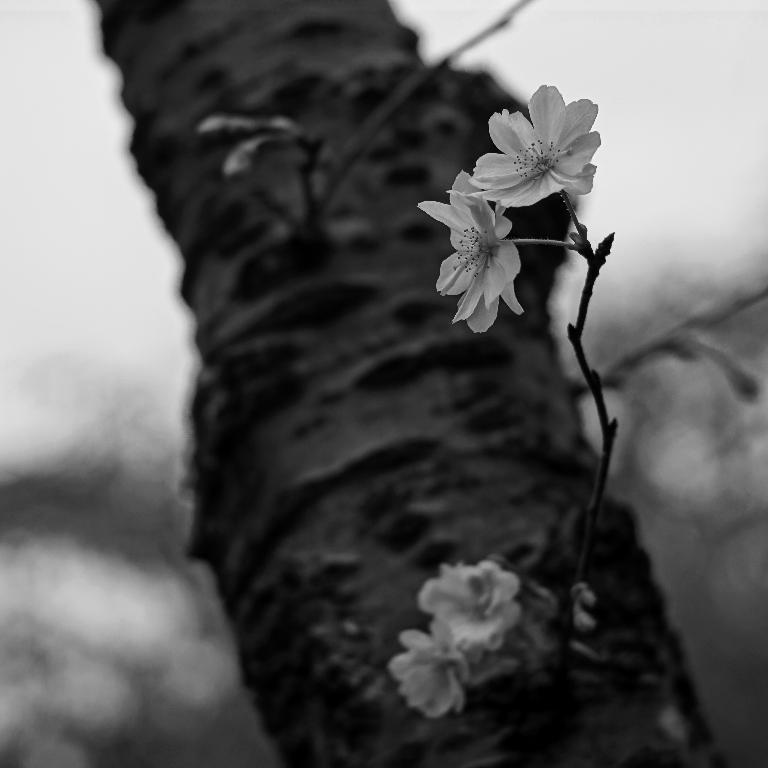What is the main subject of the image? The main subject of the image is flowers. Can you describe the flowers in the image? The flowers are located in the center of the image. What can be observed about the background of the image? The background of the image is blurry. How many dolls are holding onto the flowers in the image? There are no dolls present in the image, and therefore no dolls are holding onto the flowers. 